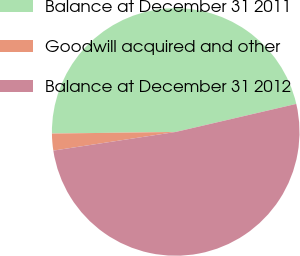Convert chart to OTSL. <chart><loc_0><loc_0><loc_500><loc_500><pie_chart><fcel>Balance at December 31 2011<fcel>Goodwill acquired and other<fcel>Balance at December 31 2012<nl><fcel>46.57%<fcel>2.2%<fcel>51.23%<nl></chart> 